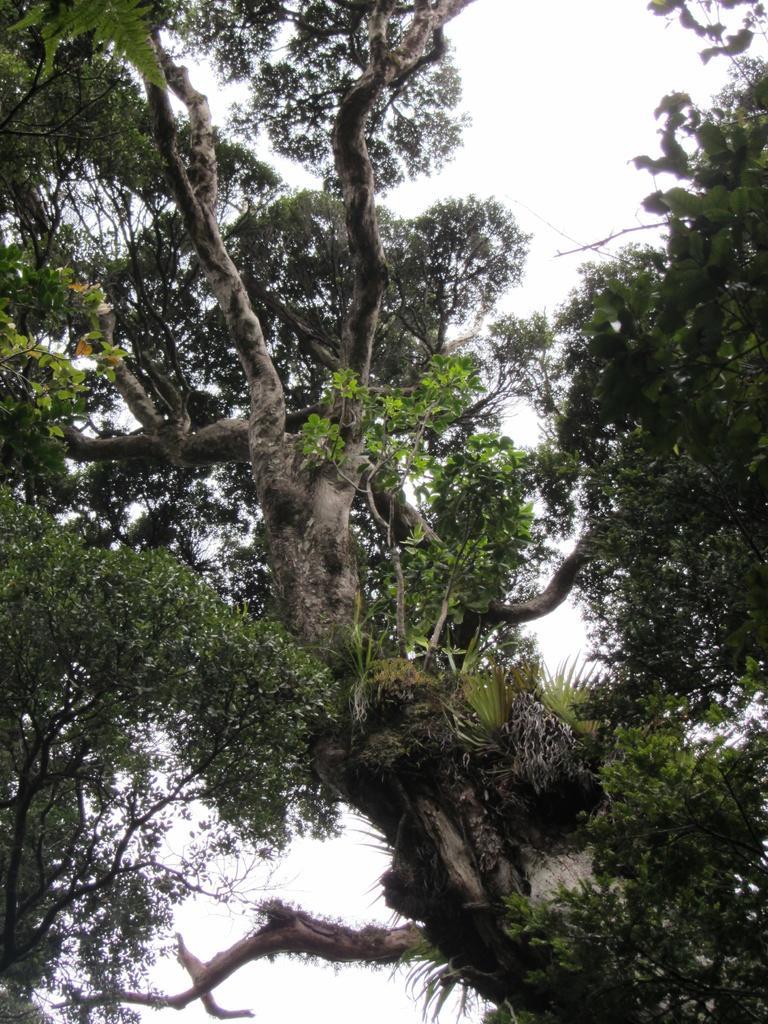Please provide a concise description of this image. In this picture I can see there are few trees with branches and there are leaves. The sky is clear. 